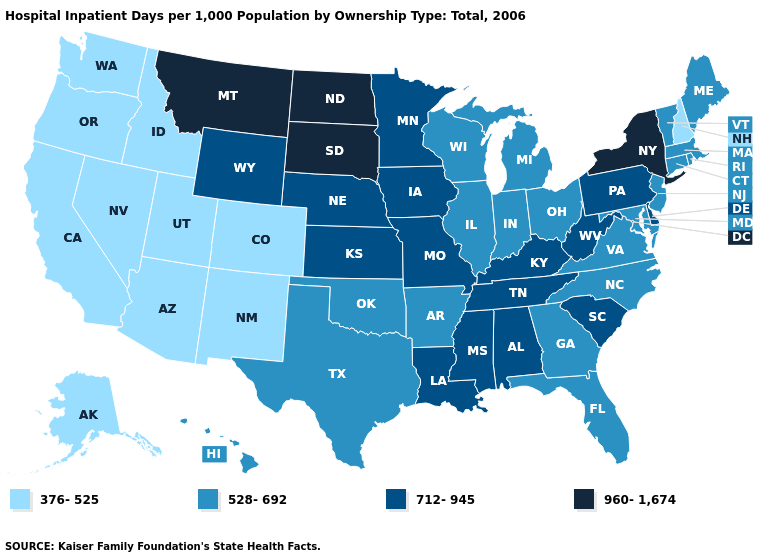Does the map have missing data?
Give a very brief answer. No. Name the states that have a value in the range 376-525?
Write a very short answer. Alaska, Arizona, California, Colorado, Idaho, Nevada, New Hampshire, New Mexico, Oregon, Utah, Washington. What is the value of Kentucky?
Keep it brief. 712-945. Does Delaware have the lowest value in the USA?
Concise answer only. No. How many symbols are there in the legend?
Concise answer only. 4. What is the value of Michigan?
Write a very short answer. 528-692. Among the states that border Indiana , which have the highest value?
Write a very short answer. Kentucky. Does Connecticut have the lowest value in the USA?
Concise answer only. No. Among the states that border Alabama , does Florida have the lowest value?
Quick response, please. Yes. Name the states that have a value in the range 960-1,674?
Answer briefly. Montana, New York, North Dakota, South Dakota. What is the highest value in states that border Delaware?
Concise answer only. 712-945. Which states hav the highest value in the West?
Short answer required. Montana. What is the value of Colorado?
Give a very brief answer. 376-525. What is the value of Montana?
Write a very short answer. 960-1,674. What is the highest value in the West ?
Quick response, please. 960-1,674. 